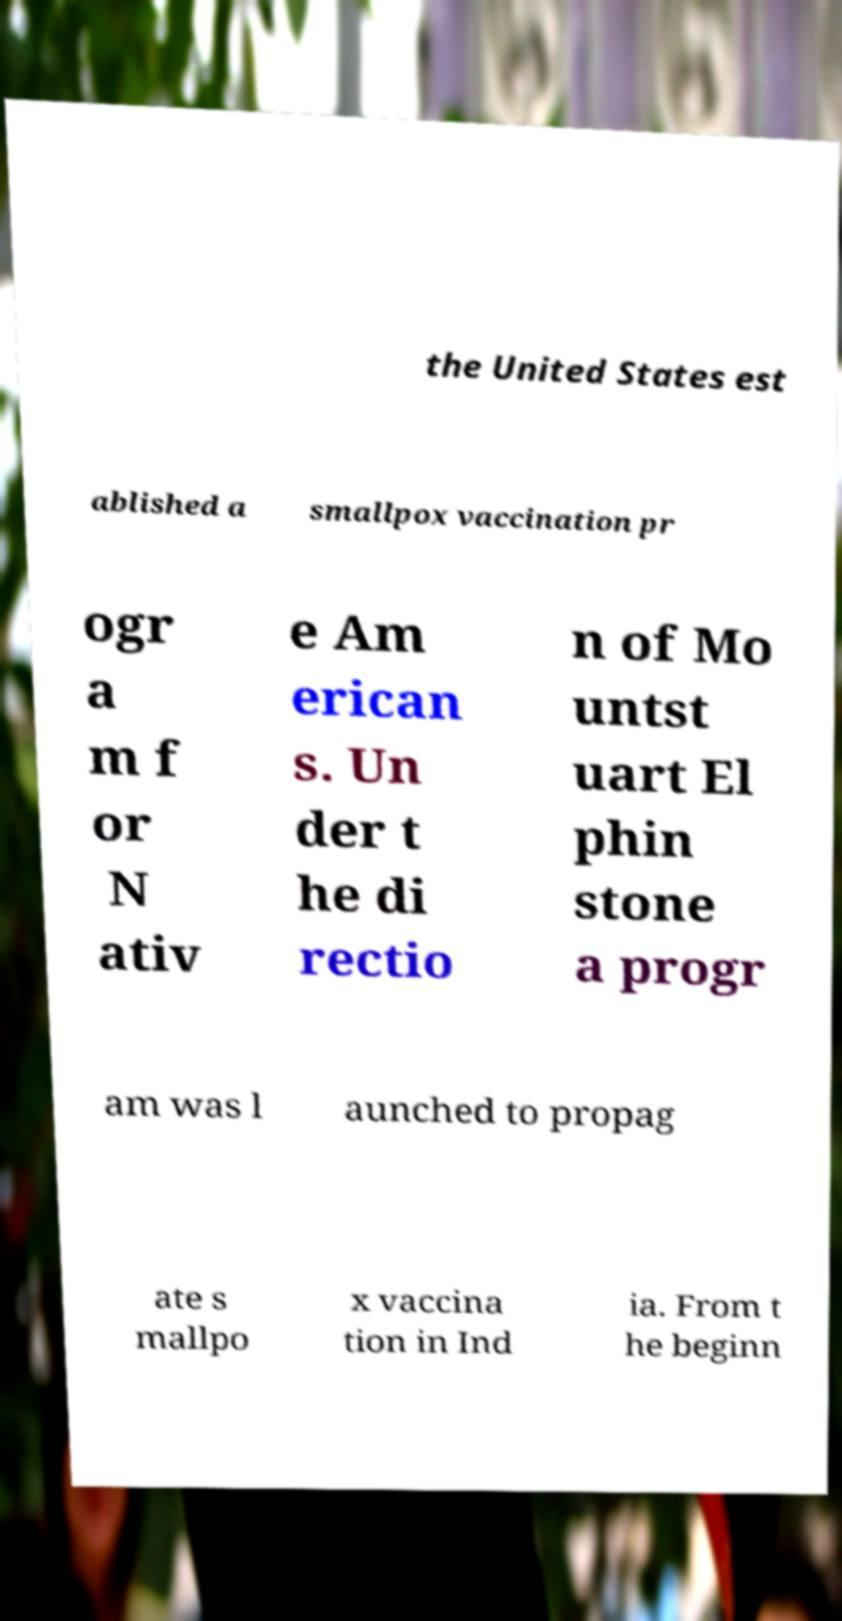I need the written content from this picture converted into text. Can you do that? the United States est ablished a smallpox vaccination pr ogr a m f or N ativ e Am erican s. Un der t he di rectio n of Mo untst uart El phin stone a progr am was l aunched to propag ate s mallpo x vaccina tion in Ind ia. From t he beginn 